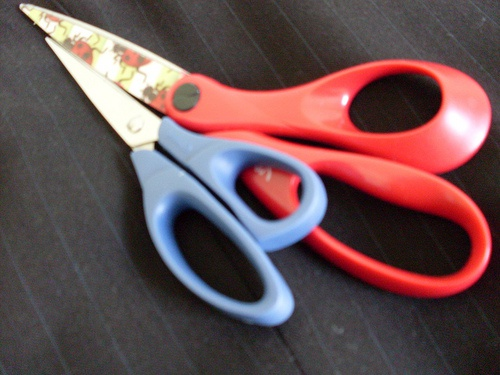Describe the objects in this image and their specific colors. I can see scissors in black, salmon, and red tones and scissors in black, lightblue, and ivory tones in this image. 